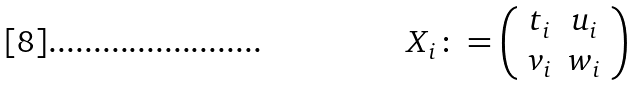<formula> <loc_0><loc_0><loc_500><loc_500>X _ { i } \colon = \left ( \begin{array} { c c } t _ { i } & u _ { i } \\ v _ { i } & w _ { i } \end{array} \right )</formula> 